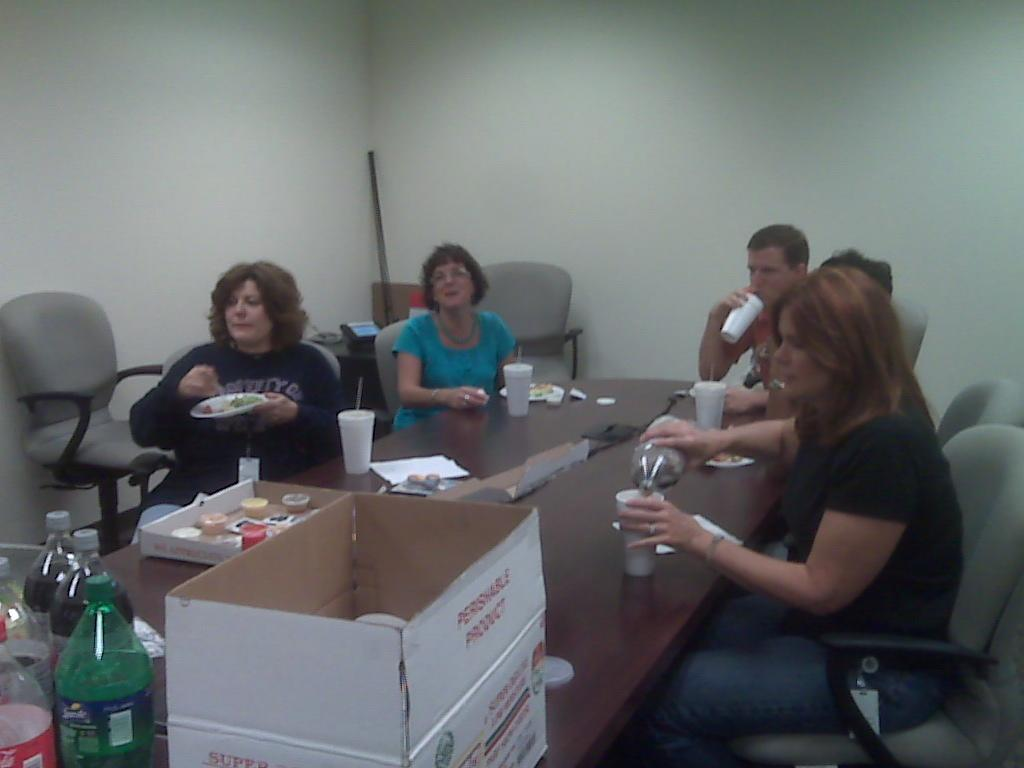How many people are in the image? There is a group of people in the image. What are the people doing in the image? The people are sitting on a chair. Where is the chair located in relation to the table? The chair is in front of a table. What is on the table besides the chair? There is a box and other objects on the table. What type of cord is being used by the writer in the image? There is no writer or cord present in the image. 